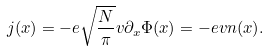<formula> <loc_0><loc_0><loc_500><loc_500>j ( x ) = - e \sqrt { \frac { N } { \pi } } v \partial _ { x } \Phi ( x ) = - e v n ( x ) .</formula> 